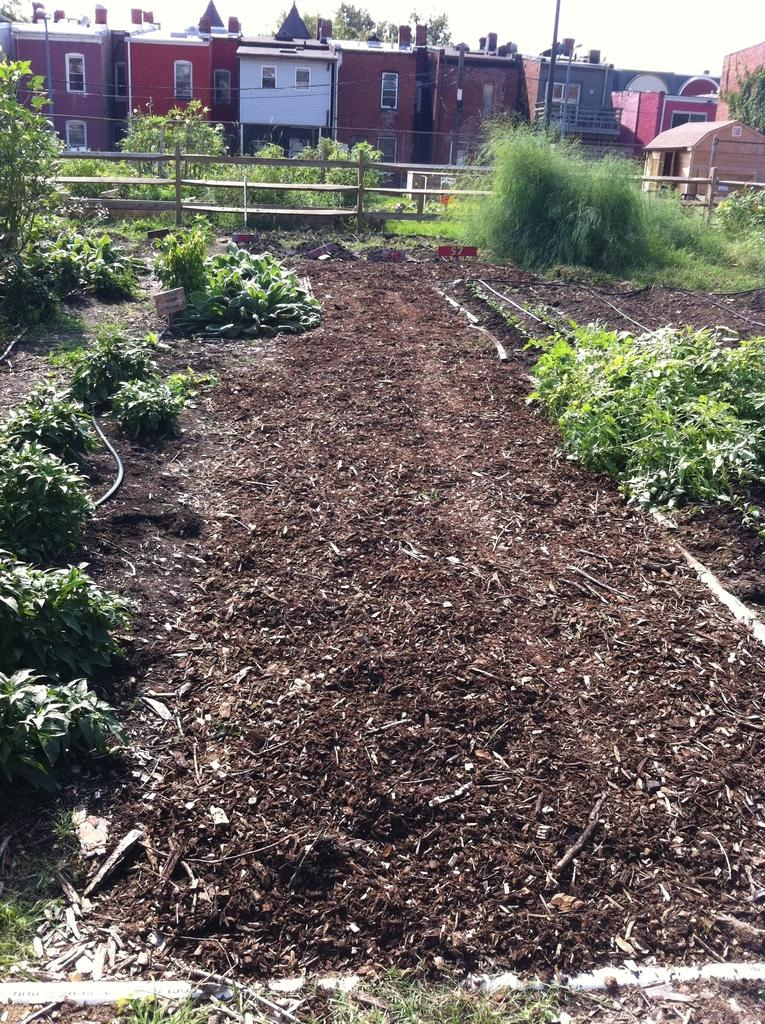What type of living organisms can be seen in the image? Plants can be seen in the image. What type of structure is present in the image? There is a wooden fence in the image. What are the tall, thin objects in the image? There are poles in the image. What can be seen in the background of the image? Trees and buildings are visible in the background of the image. What type of jeans is the plant wearing in the image? There are no jeans present in the image, as plants do not wear clothing. 